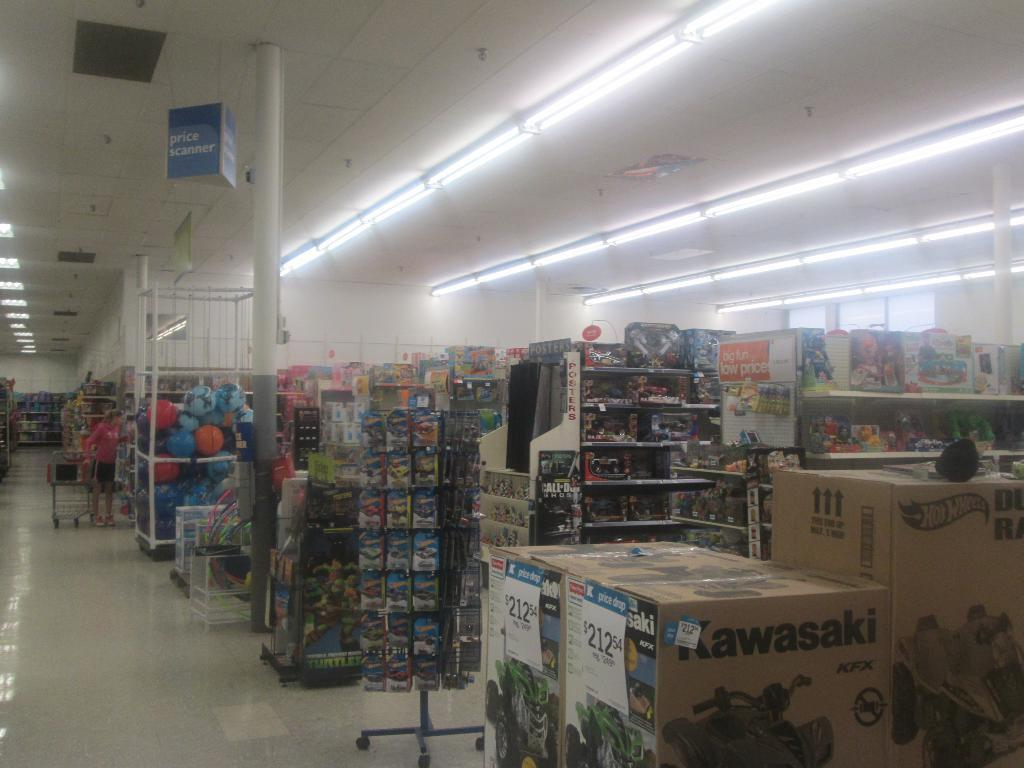<image>
Offer a succinct explanation of the picture presented. Some Kawasaki boxes sit at the end of a store aisle. 